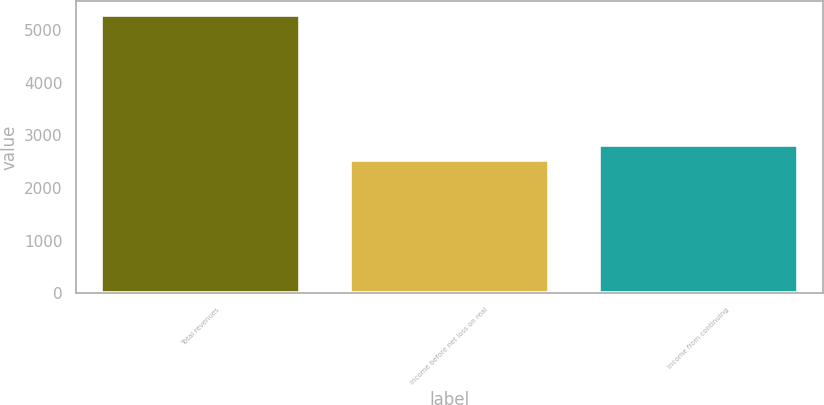<chart> <loc_0><loc_0><loc_500><loc_500><bar_chart><fcel>Total revenues<fcel>Income before net loss on real<fcel>Income from continuing<nl><fcel>5293<fcel>2533<fcel>2809<nl></chart> 